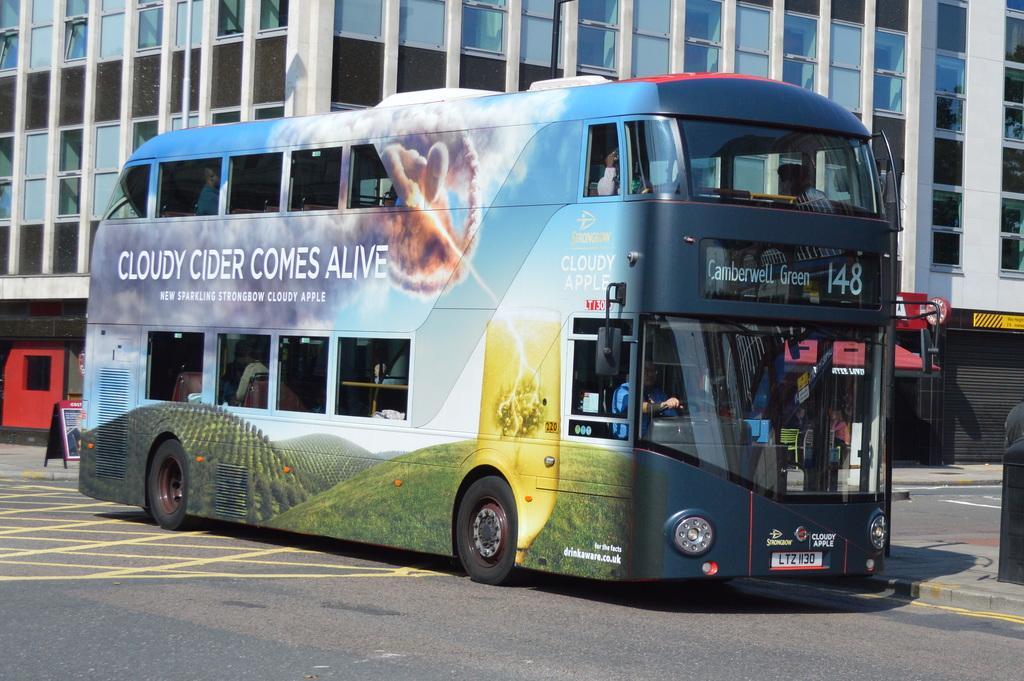Please provide a concise description of this image. In the center of the image we can see a bus with people on the road. In the background we can see the building. We can also see an informational board on the path which is on the left. On the right we can see a black color object. 